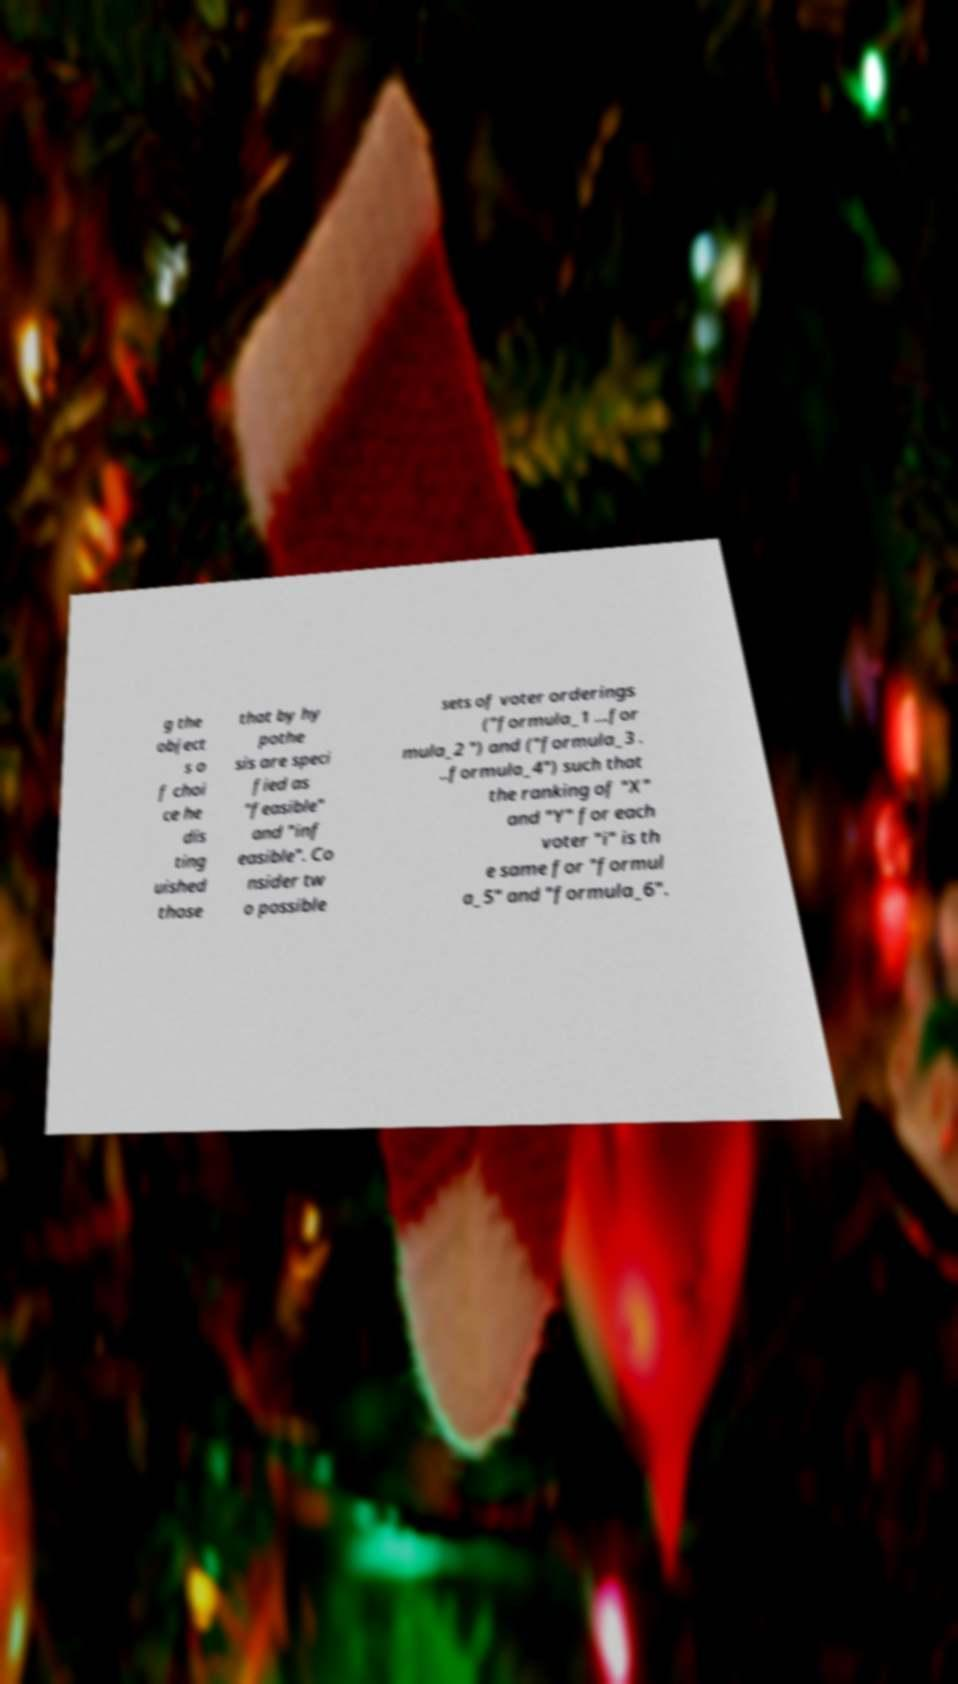What messages or text are displayed in this image? I need them in a readable, typed format. g the object s o f choi ce he dis ting uished those that by hy pothe sis are speci fied as "feasible" and "inf easible". Co nsider tw o possible sets of voter orderings ("formula_1 ...for mula_2 ") and ("formula_3 . ..formula_4") such that the ranking of "X" and "Y" for each voter "i" is th e same for "formul a_5" and "formula_6". 